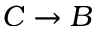Convert formula to latex. <formula><loc_0><loc_0><loc_500><loc_500>C \rightarrow B</formula> 